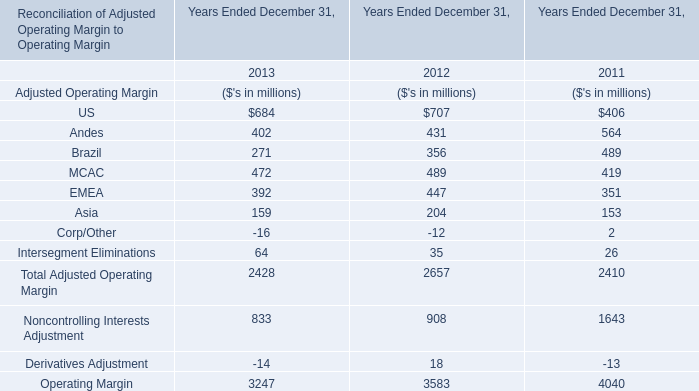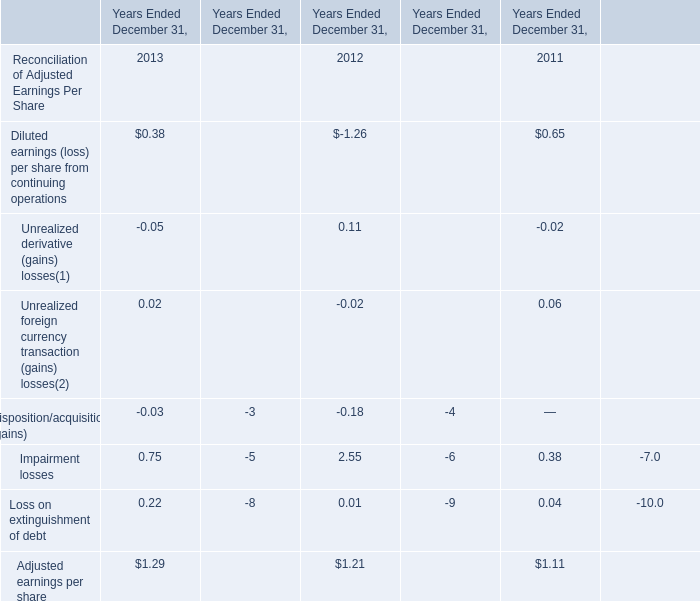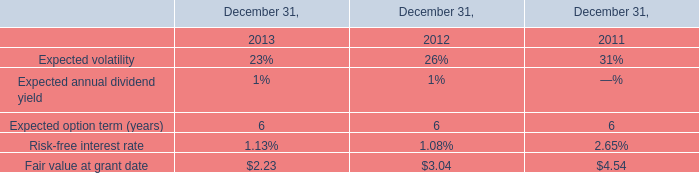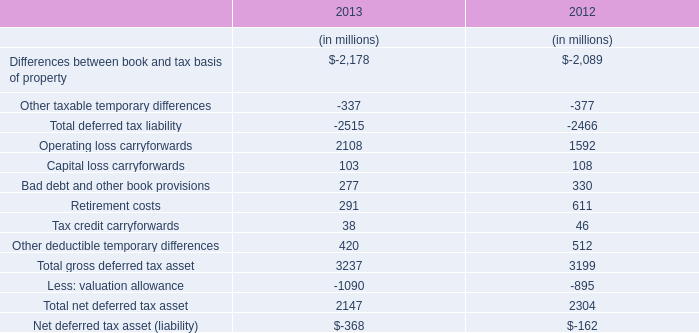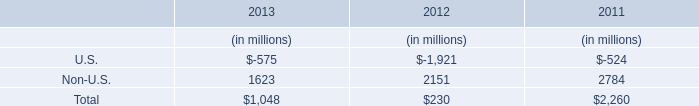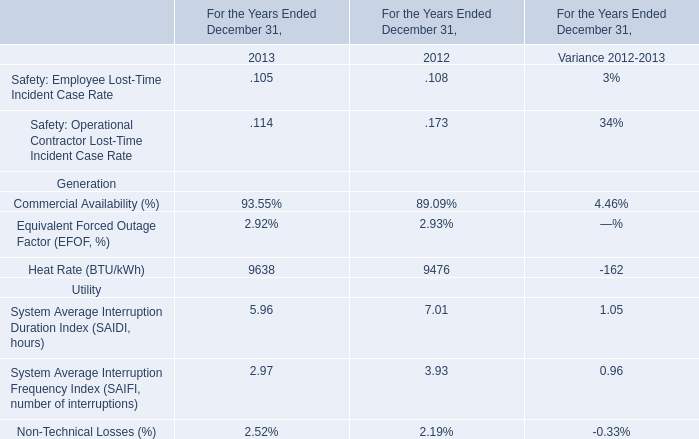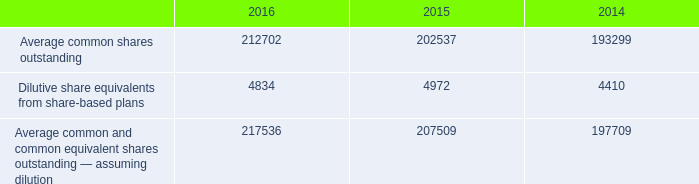What's the current growth rate of Asia for Adjusted Operating Margin? (in %) 
Computations: ((159 - 204) / 204)
Answer: -0.22059. 